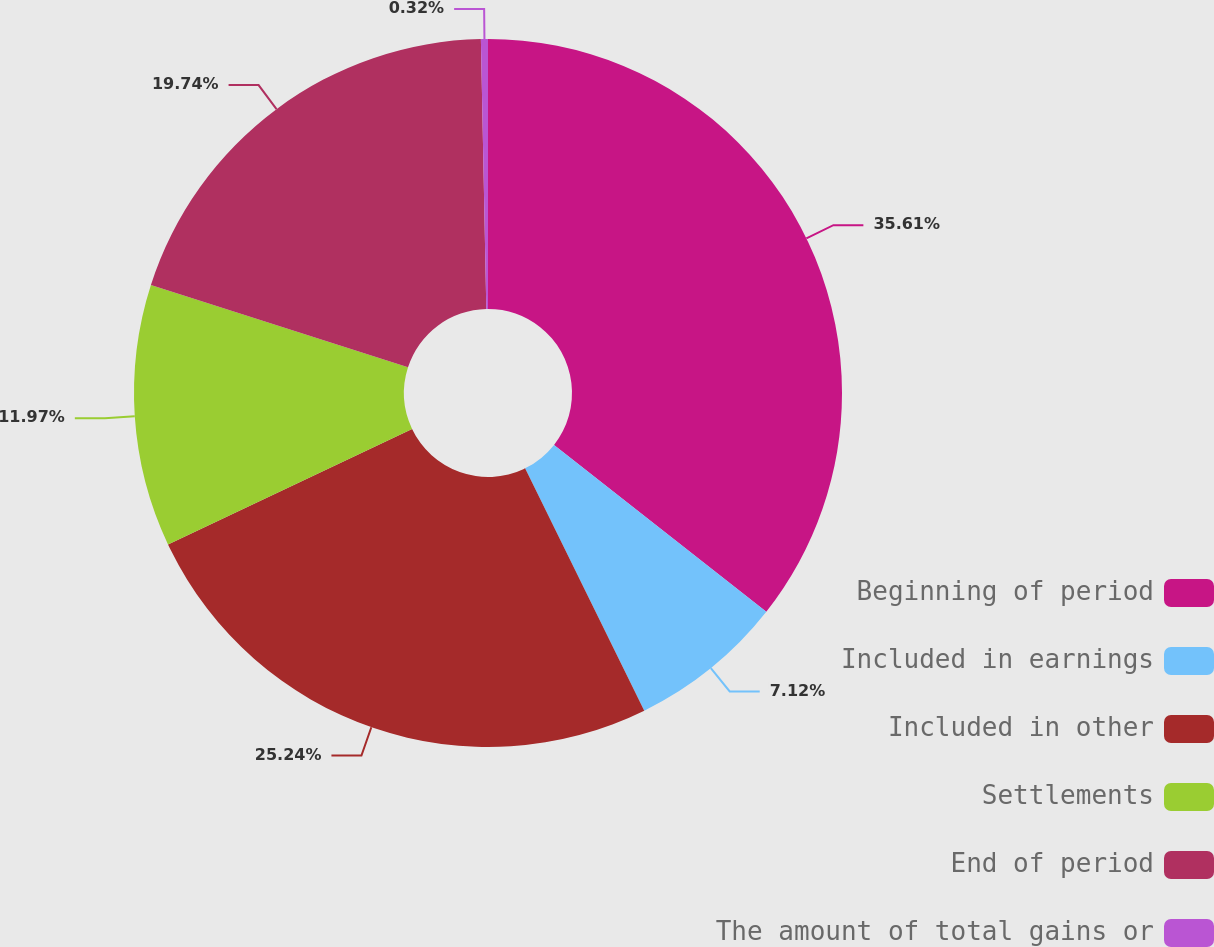Convert chart to OTSL. <chart><loc_0><loc_0><loc_500><loc_500><pie_chart><fcel>Beginning of period<fcel>Included in earnings<fcel>Included in other<fcel>Settlements<fcel>End of period<fcel>The amount of total gains or<nl><fcel>35.6%<fcel>7.12%<fcel>25.24%<fcel>11.97%<fcel>19.74%<fcel>0.32%<nl></chart> 